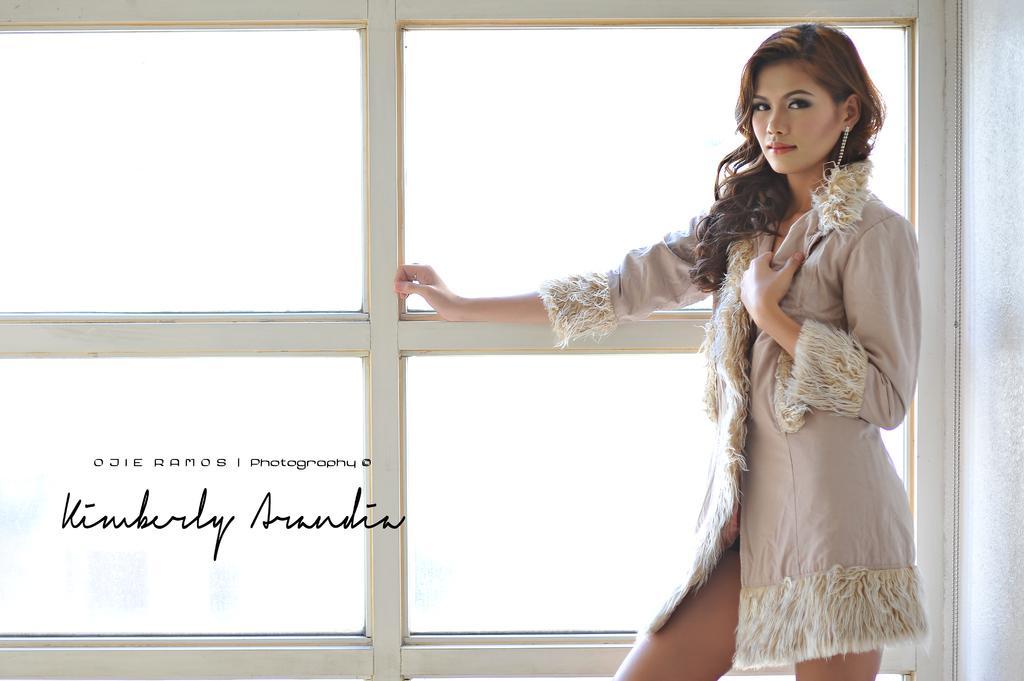How would you summarize this image in a sentence or two? In this picture there is a woman standing in the right corner and placed her hand on a glass window beside her and there is something written in the left bottom corner. 